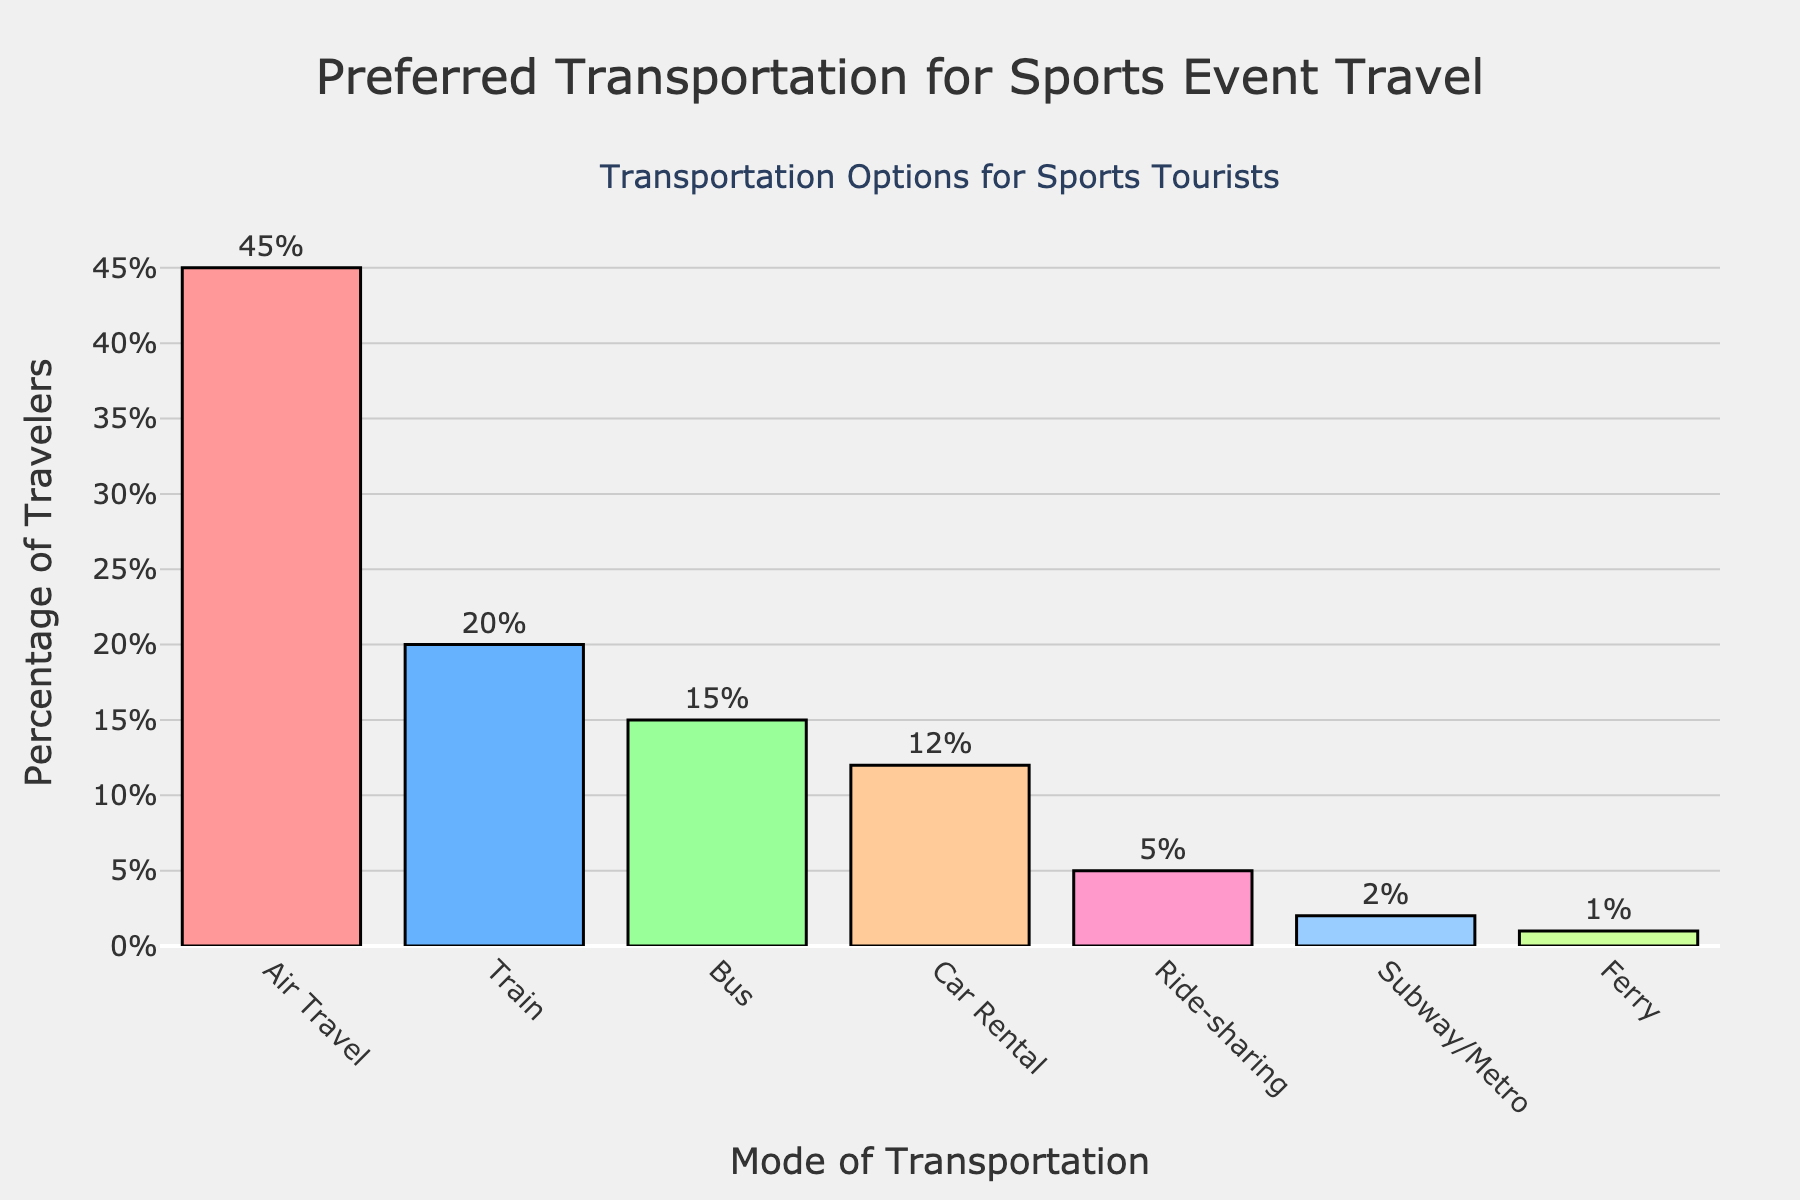What's the most commonly used mode of transportation by sports tourists? The bar representing 'Air Travel' is the tallest, indicating it has the highest percentage compared to others.
Answer: Air Travel Which mode of transportation is used by the smallest percentage of sports tourists? The smallest bar in the chart is for 'Ferry', implying it has the lowest percentage.
Answer: Ferry How many times more popular is air travel compared to subway/metro? Air Travel has a percentage of 45%, and Subway/Metro has 2%. Divide 45 by 2 to get the ratio.
Answer: 22.5 times What is the combined percentage of sports tourists using either bus or car rental? Add the percentages for the bus (15%) and car rental (12%) to get the total percentage.
Answer: 27% Which transportation modes have a usage percentage greater than 10%? The bars for Air Travel (45%), Train (20%), Bus (15%), and Car Rental (12%) are all above 10%.
Answer: Air Travel, Train, Bus, Car Rental What is the average percentage of use for ride-sharing and subway/metro? Add the percentages of ride-sharing (5%) and subway/metro (2%), then divide by 2.
Answer: 3.5% Is the percentage of bus users closer to the percentage of train users or car rental users? The percentage for bus users is 15%. The distance to train users (20%) is 5%, and the distance to car rental users (12%) is 3%. Hence, it is closer to car rental users.
Answer: Car Rental By how much does the percentage of air travelers exceed the combined percentage of bus and ride-sharing users? Air travel is at 45%. Bus and ride-sharing combined is 15% + 5% = 20%. Subtract 20% from 45%.
Answer: 25% What is the median usage percentage for all the transportation modes listed? Organize the percentages in ascending order: 1%, 2%, 5%, 12%, 15%, 20%, 45%. The median is the middle value.
Answer: 12% Which mode of transportation has a percentage less than but closest to train travel? Train travel is at 20%. The closest lower percentage is for bus travel, which is 15%.
Answer: Bus 